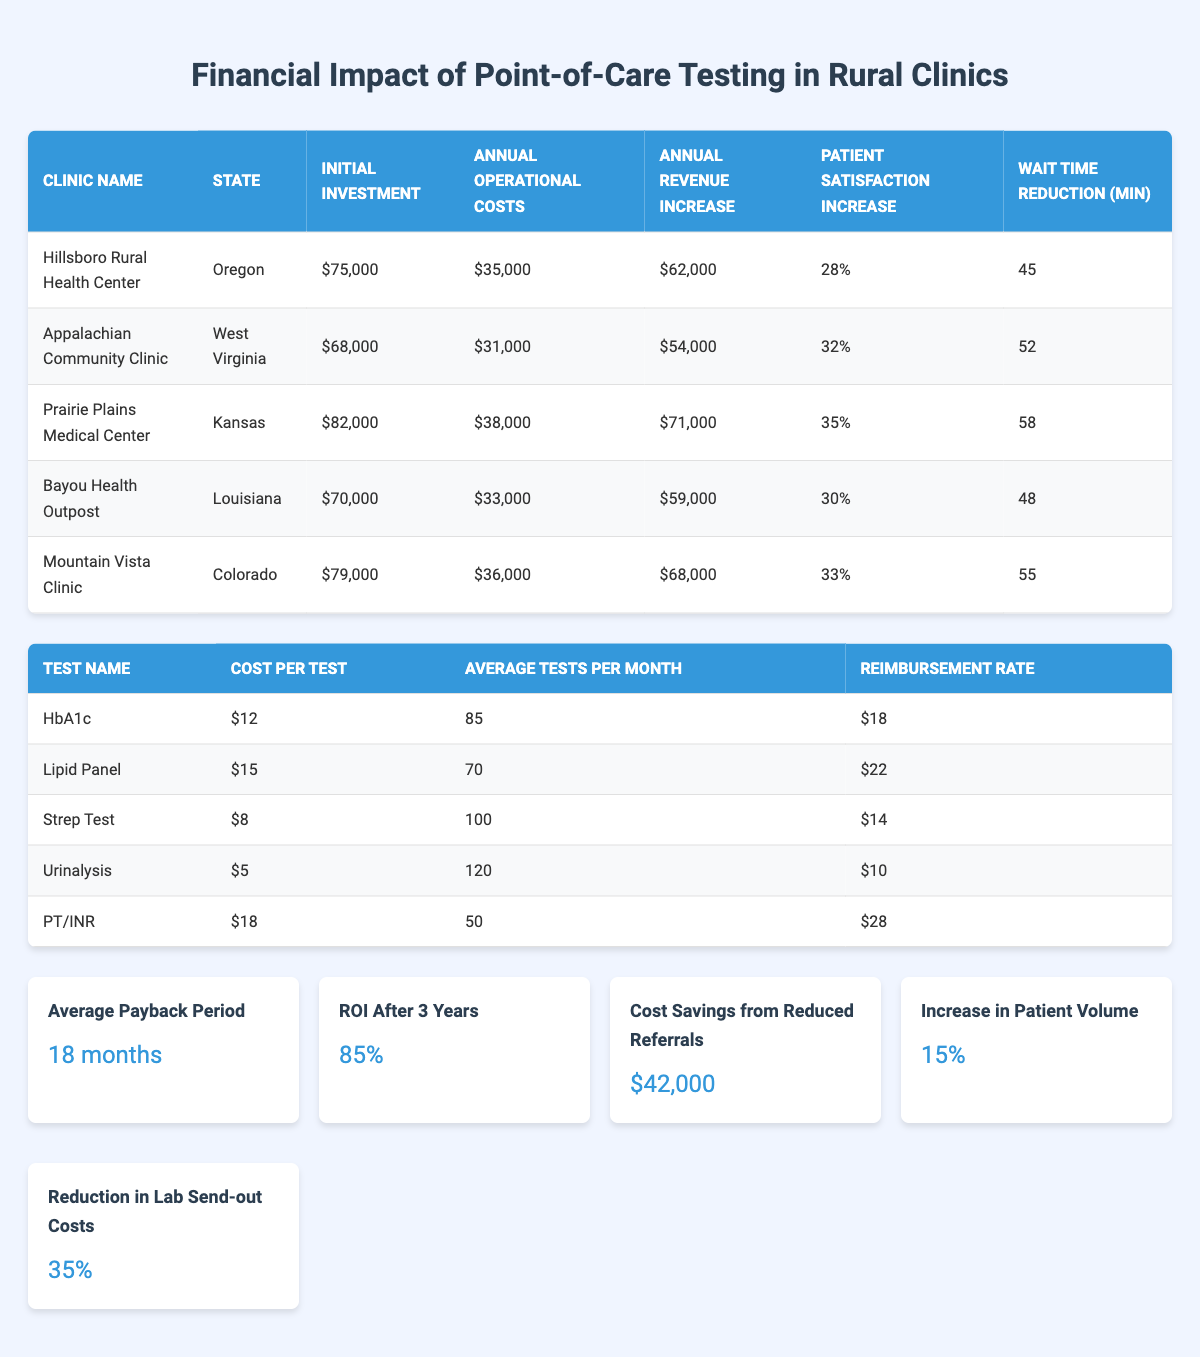What is the initial investment for Prairie Plains Medical Center? The table lists the initial investment for each clinic. For Prairie Plains Medical Center, the value is $82,000 as shown in the table.
Answer: $82,000 Which clinic has the highest annual revenue increase? By comparing the annual revenue increases for each clinic listed, Prairie Plains Medical Center shows the highest value of $71,000, which is greater than the values for the other clinics.
Answer: Prairie Plains Medical Center Is the annual operational cost for Bayou Health Outpost higher than for Appalachian Community Clinic? The annual operational cost for Bayou Health Outpost is $33,000 and for Appalachian Community Clinic it is $31,000. Since $33,000 is greater than $31,000, the statement is true.
Answer: Yes What is the average wait time reduction for all clinics listed? The average wait time reduction is calculated as the sum of the wait time reductions for all clinics divided by the number of clinics. The total is 45 + 52 + 58 + 48 + 55 = 258 minutes. Dividing this by 5 clinics gives an average of 51.6 minutes.
Answer: 51.6 minutes Does Mountain Vista Clinic have a higher patient satisfaction increase than Hillsboro Rural Health Center? The patient satisfaction increase for Mountain Vista Clinic is 33%, while Hillsboro Rural Health Center has a patient satisfaction increase of 28%. Since 33% is greater than 28%, the statement is true.
Answer: Yes Calculate the total initial investment for all clinics combined. The total initial investment is found by summing the initial investments of all listed clinics: 75000 + 68000 + 82000 + 70000 + 79000 = 394000.
Answer: $394,000 What is the percentage increase in patient volume after implementing point-of-care testing? The financial metrics state a 15% increase in patient volume, as shown in the summary section of the table.
Answer: 15% Which state has the clinic with the lowest operational costs? By comparing annual operational costs, Appalachian Community Clinic has the lowest at $31,000, which is lower than the operational costs of the other clinics listed. The state for this clinic is West Virginia.
Answer: West Virginia What is the ROI after 3 years stated in the table? The table indicates that the ROI after 3 years is 0.85, meaning it is an 85% return on investment, clearly outlined in the financial metrics section.
Answer: 85% 